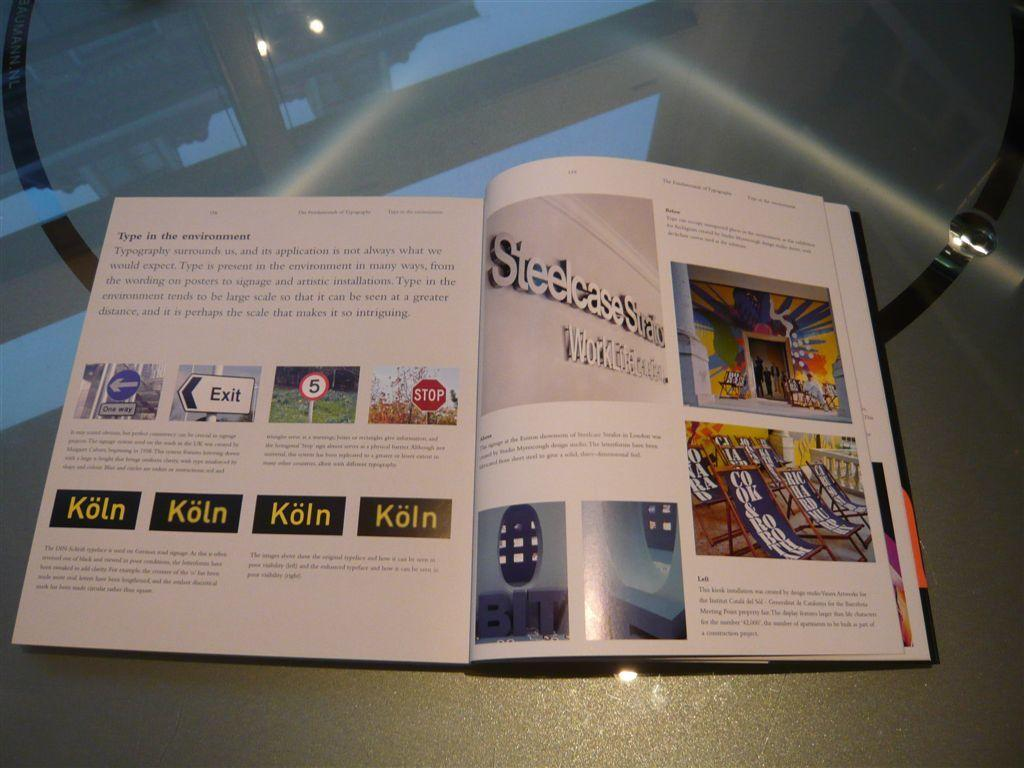<image>
Give a short and clear explanation of the subsequent image. Pages depicting signs such as an exit sign and a stop sign are laying open on a table. 